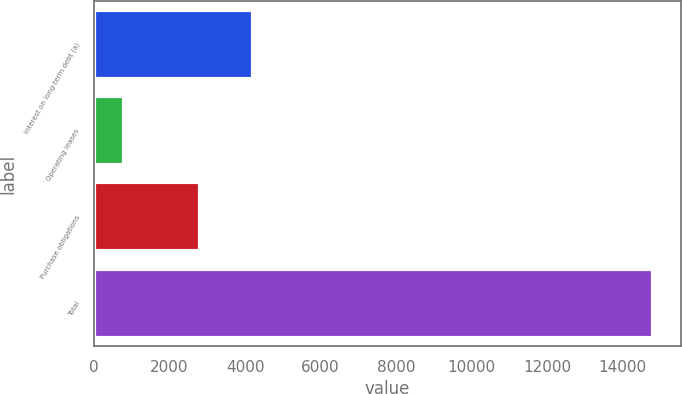Convert chart. <chart><loc_0><loc_0><loc_500><loc_500><bar_chart><fcel>Interest on long-term debt (a)<fcel>Operating leases<fcel>Purchase obligations<fcel>Total<nl><fcel>4202.2<fcel>783<fcel>2799<fcel>14815<nl></chart> 